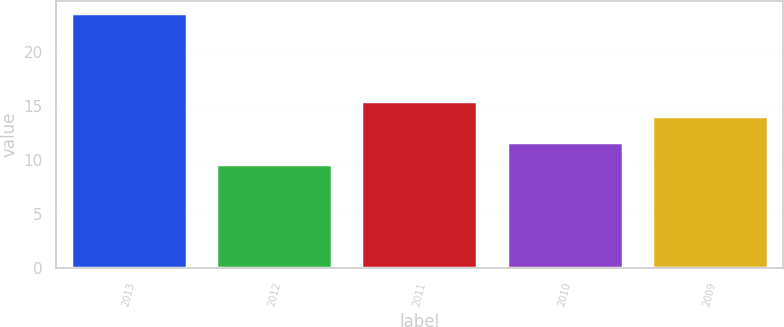<chart> <loc_0><loc_0><loc_500><loc_500><bar_chart><fcel>2013<fcel>2012<fcel>2011<fcel>2010<fcel>2009<nl><fcel>23.6<fcel>9.6<fcel>15.5<fcel>11.7<fcel>14.1<nl></chart> 